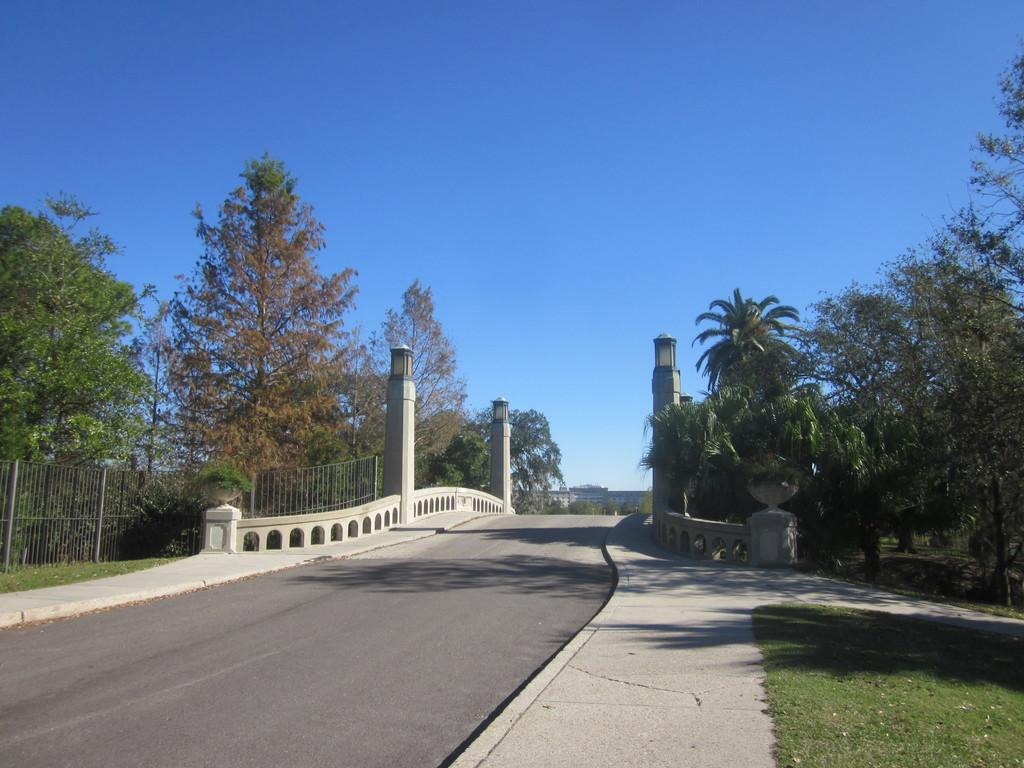What is located at the bottom of the image? There is a road at the bottom of the image. What can be seen in the image besides the road? There is a fence, trees, and pillars in the image. What is the color of the sky in the background of the image? The sky is blue in the background of the image. Where is the lunchroom located in the image? There is no lunchroom present in the image. What type of stocking is hanging on the fence in the image? There is no stocking visible in the image. 